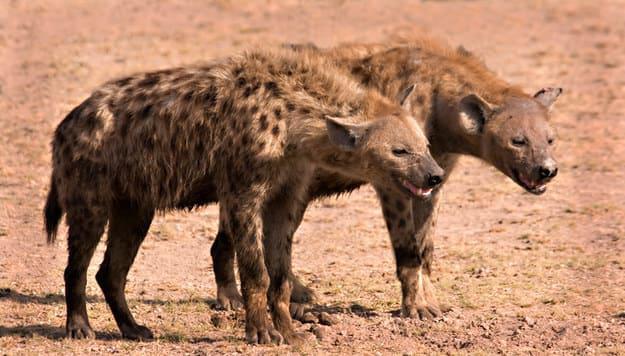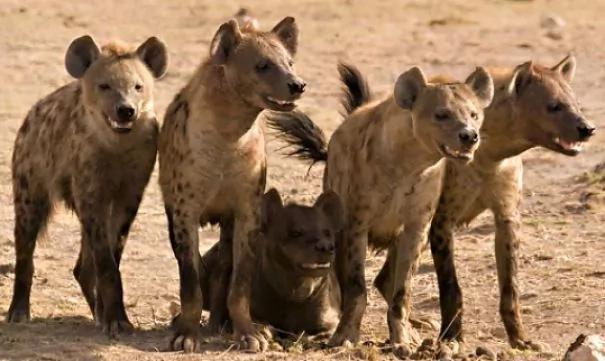The first image is the image on the left, the second image is the image on the right. Assess this claim about the two images: "One of the images shows hyenas hunting and the other shows them eating after a successful hunt.". Correct or not? Answer yes or no. No. The first image is the image on the left, the second image is the image on the right. Given the left and right images, does the statement "One image includes one standing water buffalo in the foreground near multiple hyenas, and the other image shows a pack of hyenas gathered around something on the ground." hold true? Answer yes or no. No. 